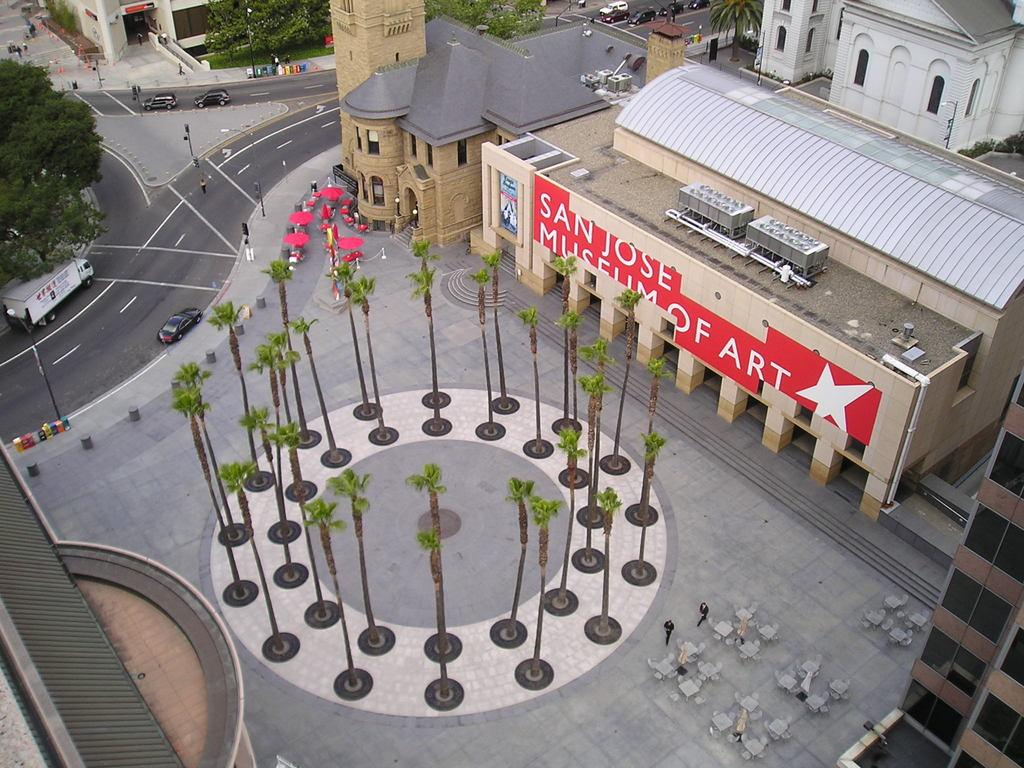What type of vegetation can be seen in the image? There are trees and grass in the image. What type of structures are present in the image? There are buildings in the image. Can you describe the people in the image? There are persons in the image. What type of seating is available in the image? There are benches in the image. What type of transportation can be seen in the image? There are vehicles in the image. What type of surface is visible in the image? There is a road in the image. What type of traffic control is present in the image? There are traffic signals in the image. How many clovers are growing on the grass in the image? There is no mention of clovers in the image, so it is impossible to determine their presence or quantity. What type of bird can be seen perched on the traffic signal in the image? There is no bird present on the traffic signal in the image. What song is being sung by the persons in the image? There is no indication that any song is being sung by the persons in the image. 